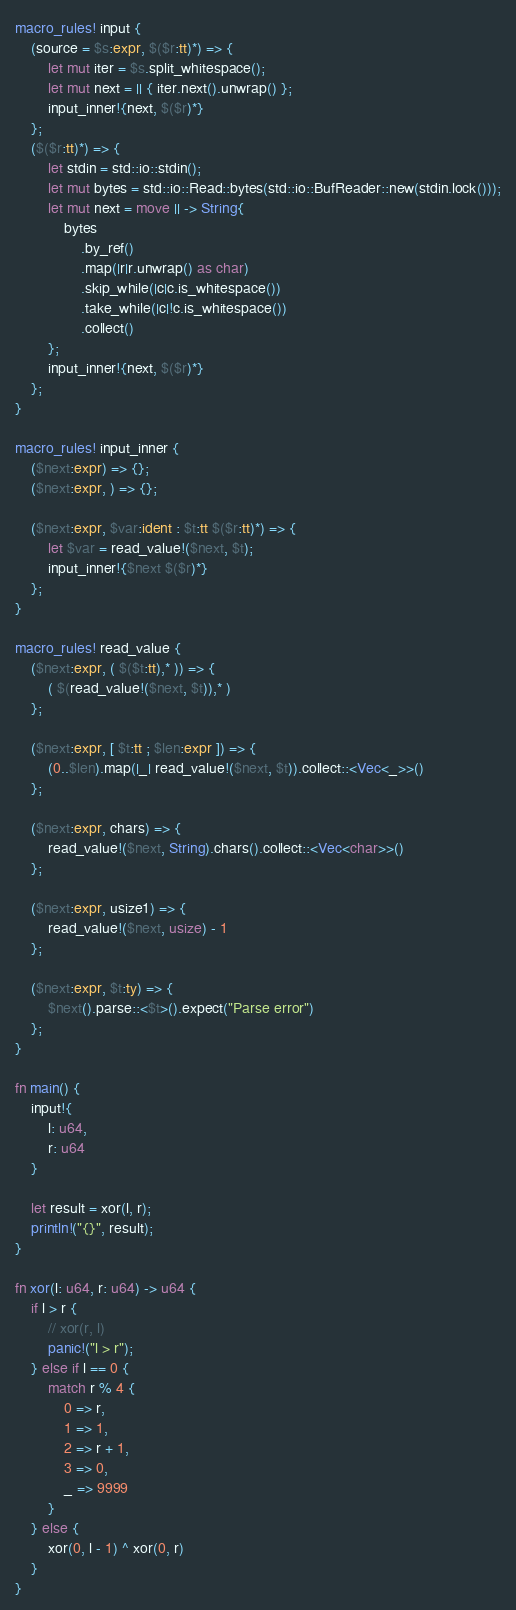Convert code to text. <code><loc_0><loc_0><loc_500><loc_500><_Rust_>macro_rules! input {
    (source = $s:expr, $($r:tt)*) => {
        let mut iter = $s.split_whitespace();
        let mut next = || { iter.next().unwrap() };
        input_inner!{next, $($r)*}
    };
    ($($r:tt)*) => {
        let stdin = std::io::stdin();
        let mut bytes = std::io::Read::bytes(std::io::BufReader::new(stdin.lock()));
        let mut next = move || -> String{
            bytes
                .by_ref()
                .map(|r|r.unwrap() as char)
                .skip_while(|c|c.is_whitespace())
                .take_while(|c|!c.is_whitespace())
                .collect()
        };
        input_inner!{next, $($r)*}
    };
}

macro_rules! input_inner {
    ($next:expr) => {};
    ($next:expr, ) => {};

    ($next:expr, $var:ident : $t:tt $($r:tt)*) => {
        let $var = read_value!($next, $t);
        input_inner!{$next $($r)*}
    };
}

macro_rules! read_value {
    ($next:expr, ( $($t:tt),* )) => {
        ( $(read_value!($next, $t)),* )
    };

    ($next:expr, [ $t:tt ; $len:expr ]) => {
        (0..$len).map(|_| read_value!($next, $t)).collect::<Vec<_>>()
    };

    ($next:expr, chars) => {
        read_value!($next, String).chars().collect::<Vec<char>>()
    };

    ($next:expr, usize1) => {
        read_value!($next, usize) - 1
    };

    ($next:expr, $t:ty) => {
        $next().parse::<$t>().expect("Parse error")
    };
}

fn main() {
    input!{
        l: u64,
        r: u64
    }

    let result = xor(l, r);
    println!("{}", result);
}

fn xor(l: u64, r: u64) -> u64 {
    if l > r {
        // xor(r, l)
        panic!("l > r");
    } else if l == 0 {
        match r % 4 {
            0 => r,
            1 => 1,
            2 => r + 1,
            3 => 0,
            _ => 9999
        }
    } else {
        xor(0, l - 1) ^ xor(0, r)
    }
}
</code> 